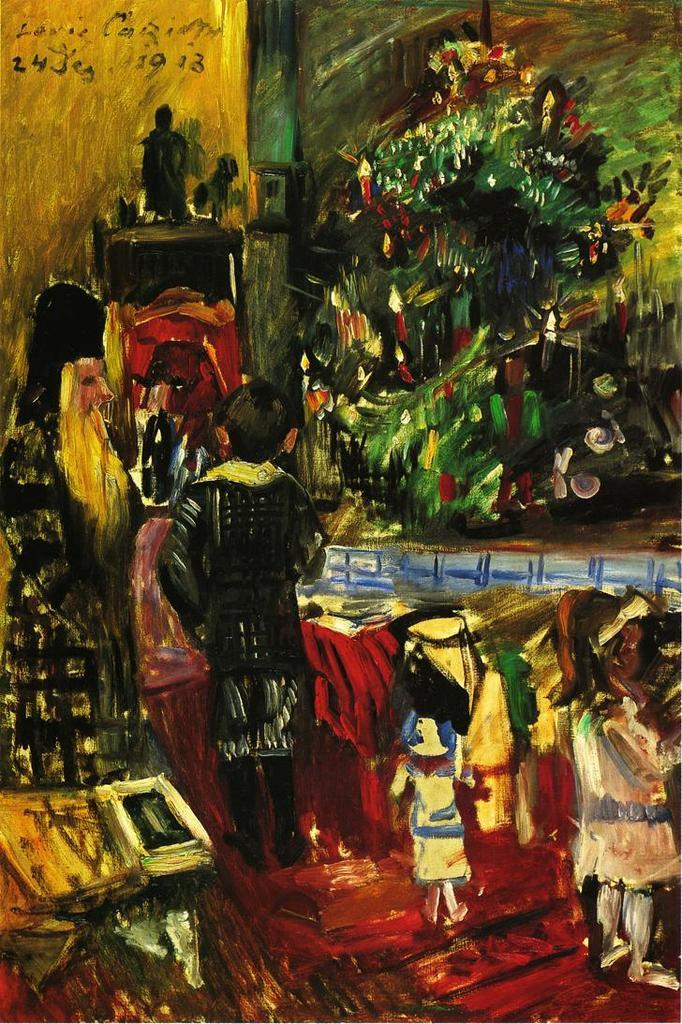What is the main subject of the image? There is a painting in the image. What else can be seen in the image besides the painting? There are people on the ground and a wall visible in the image. Can you describe the objects present in the image? There are objects present in the image, but their specific nature is not mentioned in the provided facts. What type of clock can be seen floating in space in the image? There is no clock or space present in the image; it features a painting, people on the ground, and a wall. Can you tell me how many twigs are present in the image? There is no mention of twigs in the provided facts, so it is impossible to determine their presence or quantity in the image. 